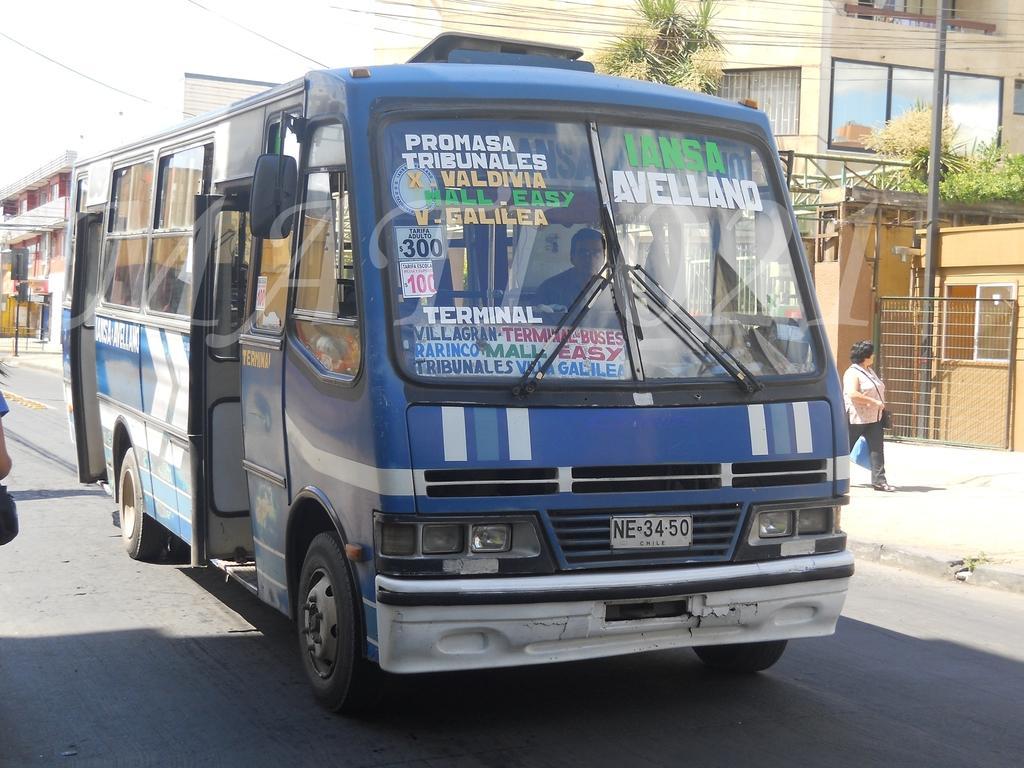How would you summarize this image in a sentence or two? In the picture we can see a mini bus on the road beside the bus we can see a path on it we can see a woman walking and beside her we can see a house building with glass window and some plants near it and a pole near the wall and behind the bus also we can see some buildings. 